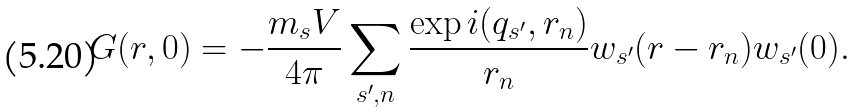Convert formula to latex. <formula><loc_0><loc_0><loc_500><loc_500>G ( r , 0 ) = - \frac { m _ { s } V } { 4 \pi } \sum _ { s ^ { \prime } , n } \frac { \exp i ( q _ { s ^ { \prime } } , r _ { n } ) } { r _ { n } } w _ { s ^ { \prime } } ( r - r _ { n } ) w _ { s ^ { \prime } } ( 0 ) .</formula> 